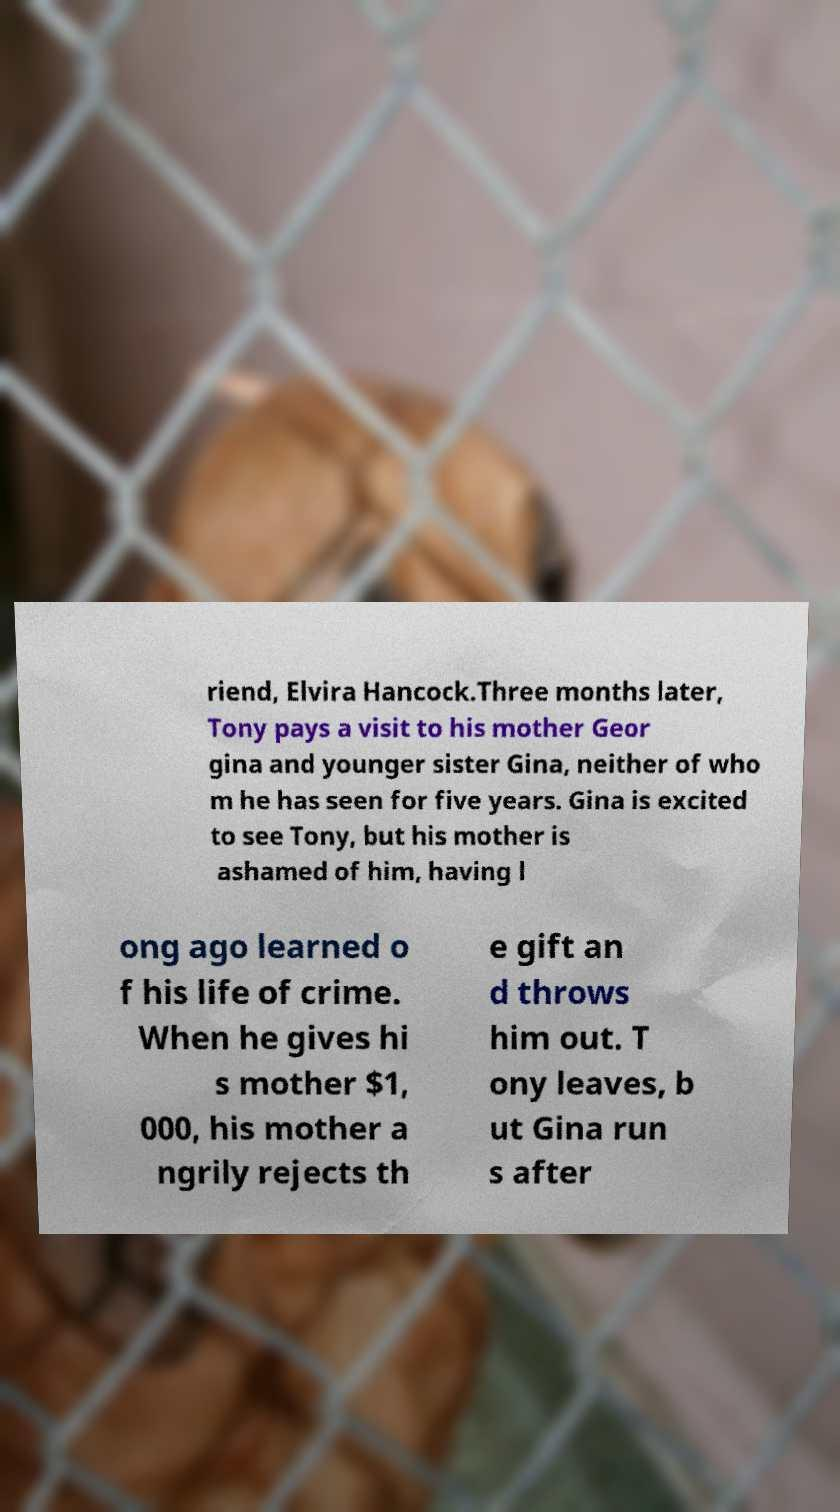Can you accurately transcribe the text from the provided image for me? riend, Elvira Hancock.Three months later, Tony pays a visit to his mother Geor gina and younger sister Gina, neither of who m he has seen for five years. Gina is excited to see Tony, but his mother is ashamed of him, having l ong ago learned o f his life of crime. When he gives hi s mother $1, 000, his mother a ngrily rejects th e gift an d throws him out. T ony leaves, b ut Gina run s after 